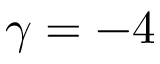Convert formula to latex. <formula><loc_0><loc_0><loc_500><loc_500>\gamma = - 4</formula> 